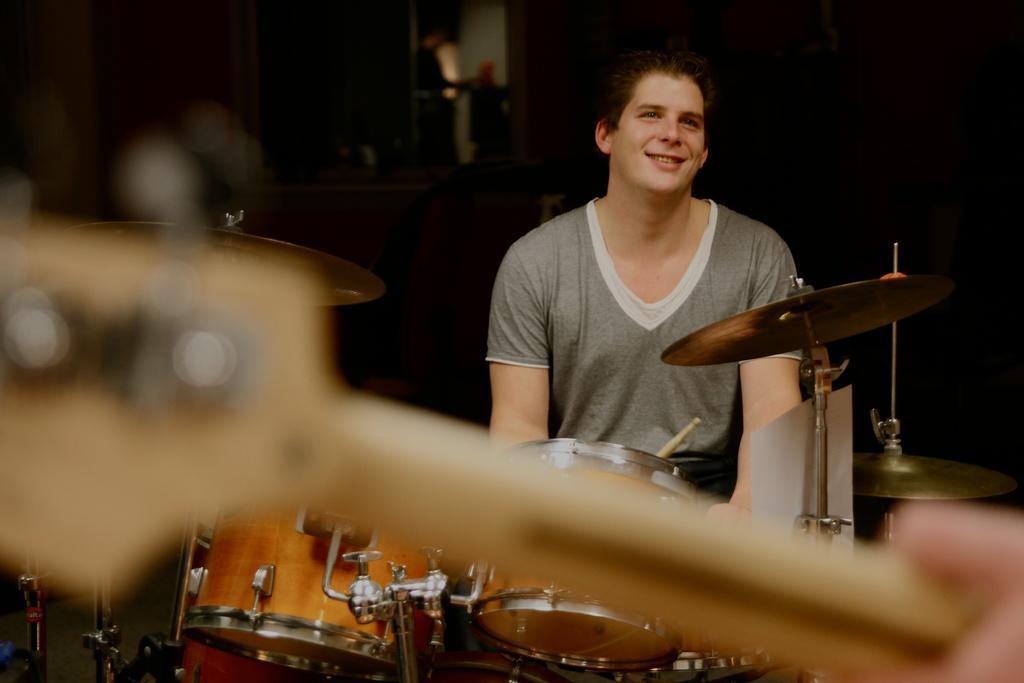Please provide a concise description of this image. In the image there is a man there are some drums in front of him, he is smiling and the background of the man is blur. 